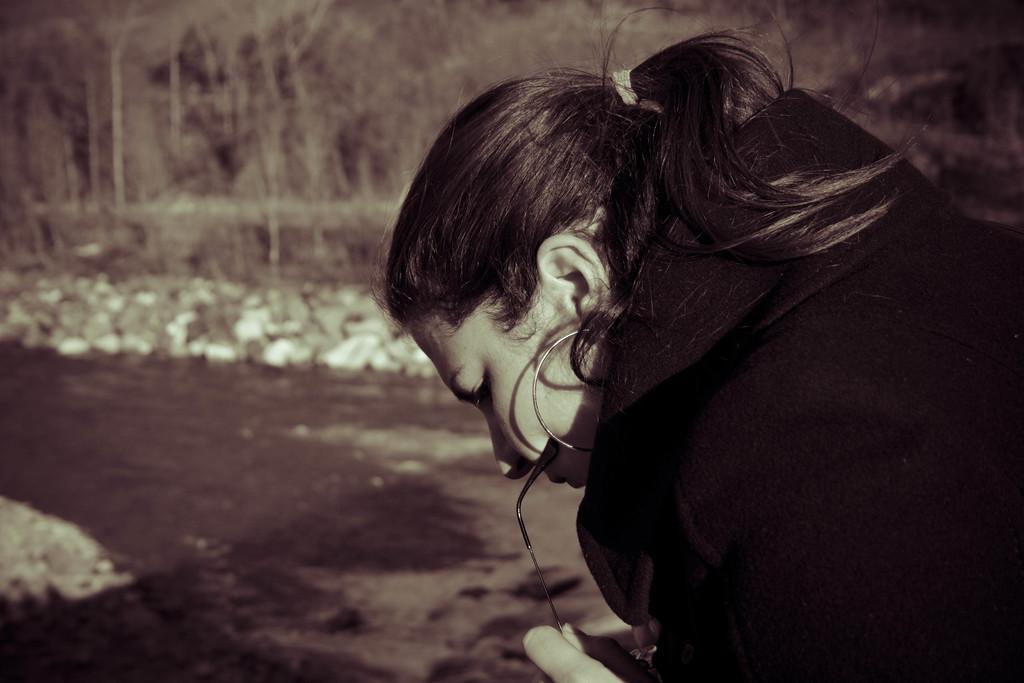Describe this image in one or two sentences. In this picture we can see a woman and behind the women there are trees. 